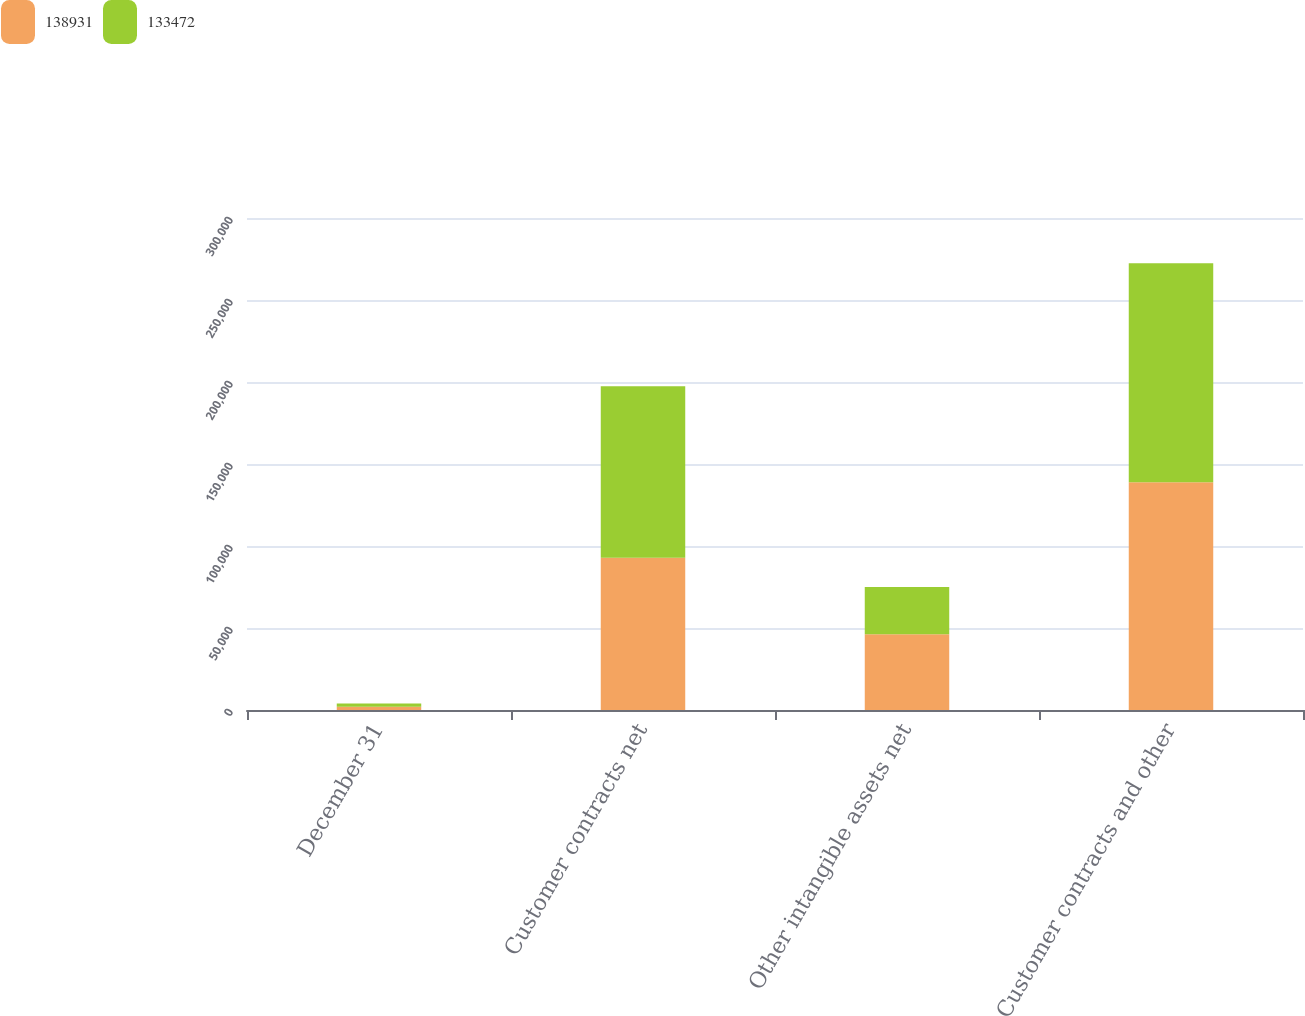Convert chart to OTSL. <chart><loc_0><loc_0><loc_500><loc_500><stacked_bar_chart><ecel><fcel>December 31<fcel>Customer contracts net<fcel>Other intangible assets net<fcel>Customer contracts and other<nl><fcel>138931<fcel>2015<fcel>92815<fcel>46116<fcel>138931<nl><fcel>133472<fcel>2014<fcel>104657<fcel>28815<fcel>133472<nl></chart> 